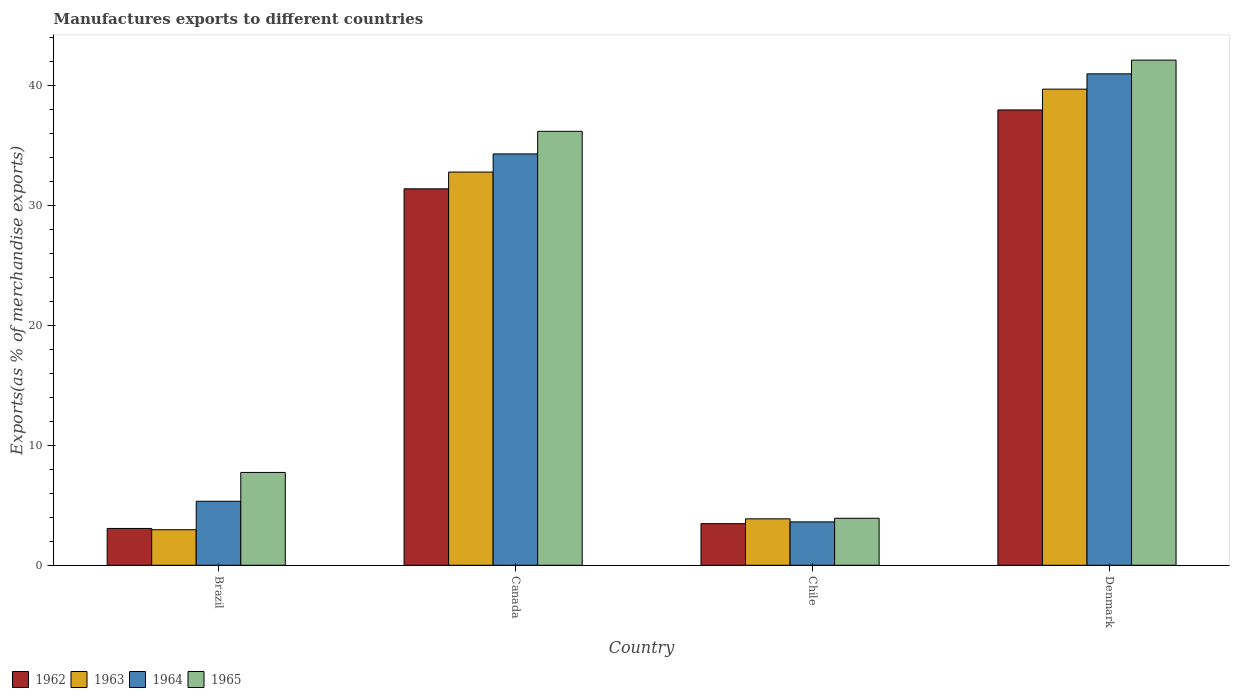How many different coloured bars are there?
Offer a terse response. 4. Are the number of bars per tick equal to the number of legend labels?
Provide a succinct answer. Yes. Are the number of bars on each tick of the X-axis equal?
Provide a succinct answer. Yes. How many bars are there on the 3rd tick from the left?
Your response must be concise. 4. How many bars are there on the 1st tick from the right?
Ensure brevity in your answer.  4. In how many cases, is the number of bars for a given country not equal to the number of legend labels?
Your answer should be very brief. 0. What is the percentage of exports to different countries in 1963 in Denmark?
Give a very brief answer. 39.71. Across all countries, what is the maximum percentage of exports to different countries in 1963?
Offer a terse response. 39.71. Across all countries, what is the minimum percentage of exports to different countries in 1962?
Provide a succinct answer. 3.07. In which country was the percentage of exports to different countries in 1965 maximum?
Ensure brevity in your answer.  Denmark. What is the total percentage of exports to different countries in 1965 in the graph?
Your response must be concise. 89.97. What is the difference between the percentage of exports to different countries in 1965 in Canada and that in Chile?
Your answer should be compact. 32.27. What is the difference between the percentage of exports to different countries in 1963 in Brazil and the percentage of exports to different countries in 1965 in Chile?
Provide a short and direct response. -0.96. What is the average percentage of exports to different countries in 1965 per country?
Ensure brevity in your answer.  22.49. What is the difference between the percentage of exports to different countries of/in 1964 and percentage of exports to different countries of/in 1963 in Brazil?
Ensure brevity in your answer.  2.37. In how many countries, is the percentage of exports to different countries in 1964 greater than 42 %?
Make the answer very short. 0. What is the ratio of the percentage of exports to different countries in 1962 in Brazil to that in Canada?
Offer a very short reply. 0.1. Is the percentage of exports to different countries in 1962 in Brazil less than that in Denmark?
Provide a succinct answer. Yes. Is the difference between the percentage of exports to different countries in 1964 in Chile and Denmark greater than the difference between the percentage of exports to different countries in 1963 in Chile and Denmark?
Your answer should be very brief. No. What is the difference between the highest and the second highest percentage of exports to different countries in 1963?
Keep it short and to the point. 28.92. What is the difference between the highest and the lowest percentage of exports to different countries in 1964?
Your response must be concise. 37.36. In how many countries, is the percentage of exports to different countries in 1965 greater than the average percentage of exports to different countries in 1965 taken over all countries?
Your answer should be very brief. 2. What does the 2nd bar from the left in Brazil represents?
Provide a short and direct response. 1963. What does the 4th bar from the right in Denmark represents?
Offer a very short reply. 1962. Is it the case that in every country, the sum of the percentage of exports to different countries in 1965 and percentage of exports to different countries in 1963 is greater than the percentage of exports to different countries in 1964?
Make the answer very short. Yes. How many bars are there?
Keep it short and to the point. 16. What is the difference between two consecutive major ticks on the Y-axis?
Offer a very short reply. 10. Does the graph contain any zero values?
Offer a very short reply. No. Where does the legend appear in the graph?
Offer a terse response. Bottom left. How many legend labels are there?
Ensure brevity in your answer.  4. How are the legend labels stacked?
Your response must be concise. Horizontal. What is the title of the graph?
Offer a very short reply. Manufactures exports to different countries. What is the label or title of the Y-axis?
Your response must be concise. Exports(as % of merchandise exports). What is the Exports(as % of merchandise exports) of 1962 in Brazil?
Make the answer very short. 3.07. What is the Exports(as % of merchandise exports) in 1963 in Brazil?
Offer a very short reply. 2.96. What is the Exports(as % of merchandise exports) of 1964 in Brazil?
Ensure brevity in your answer.  5.34. What is the Exports(as % of merchandise exports) in 1965 in Brazil?
Keep it short and to the point. 7.74. What is the Exports(as % of merchandise exports) in 1962 in Canada?
Offer a very short reply. 31.39. What is the Exports(as % of merchandise exports) in 1963 in Canada?
Your answer should be compact. 32.79. What is the Exports(as % of merchandise exports) in 1964 in Canada?
Offer a terse response. 34.3. What is the Exports(as % of merchandise exports) in 1965 in Canada?
Make the answer very short. 36.19. What is the Exports(as % of merchandise exports) in 1962 in Chile?
Provide a succinct answer. 3.47. What is the Exports(as % of merchandise exports) in 1963 in Chile?
Give a very brief answer. 3.87. What is the Exports(as % of merchandise exports) of 1964 in Chile?
Your answer should be compact. 3.62. What is the Exports(as % of merchandise exports) in 1965 in Chile?
Offer a very short reply. 3.92. What is the Exports(as % of merchandise exports) in 1962 in Denmark?
Offer a terse response. 37.97. What is the Exports(as % of merchandise exports) of 1963 in Denmark?
Give a very brief answer. 39.71. What is the Exports(as % of merchandise exports) of 1964 in Denmark?
Your answer should be very brief. 40.98. What is the Exports(as % of merchandise exports) in 1965 in Denmark?
Your response must be concise. 42.12. Across all countries, what is the maximum Exports(as % of merchandise exports) in 1962?
Offer a very short reply. 37.97. Across all countries, what is the maximum Exports(as % of merchandise exports) in 1963?
Keep it short and to the point. 39.71. Across all countries, what is the maximum Exports(as % of merchandise exports) of 1964?
Keep it short and to the point. 40.98. Across all countries, what is the maximum Exports(as % of merchandise exports) in 1965?
Make the answer very short. 42.12. Across all countries, what is the minimum Exports(as % of merchandise exports) in 1962?
Offer a terse response. 3.07. Across all countries, what is the minimum Exports(as % of merchandise exports) of 1963?
Provide a short and direct response. 2.96. Across all countries, what is the minimum Exports(as % of merchandise exports) in 1964?
Provide a succinct answer. 3.62. Across all countries, what is the minimum Exports(as % of merchandise exports) in 1965?
Provide a short and direct response. 3.92. What is the total Exports(as % of merchandise exports) in 1962 in the graph?
Make the answer very short. 75.9. What is the total Exports(as % of merchandise exports) of 1963 in the graph?
Ensure brevity in your answer.  79.33. What is the total Exports(as % of merchandise exports) in 1964 in the graph?
Your answer should be compact. 84.24. What is the total Exports(as % of merchandise exports) of 1965 in the graph?
Provide a succinct answer. 89.97. What is the difference between the Exports(as % of merchandise exports) in 1962 in Brazil and that in Canada?
Offer a very short reply. -28.32. What is the difference between the Exports(as % of merchandise exports) in 1963 in Brazil and that in Canada?
Your answer should be very brief. -29.83. What is the difference between the Exports(as % of merchandise exports) of 1964 in Brazil and that in Canada?
Offer a terse response. -28.97. What is the difference between the Exports(as % of merchandise exports) in 1965 in Brazil and that in Canada?
Provide a succinct answer. -28.45. What is the difference between the Exports(as % of merchandise exports) of 1962 in Brazil and that in Chile?
Provide a short and direct response. -0.4. What is the difference between the Exports(as % of merchandise exports) in 1963 in Brazil and that in Chile?
Offer a terse response. -0.91. What is the difference between the Exports(as % of merchandise exports) in 1964 in Brazil and that in Chile?
Give a very brief answer. 1.72. What is the difference between the Exports(as % of merchandise exports) in 1965 in Brazil and that in Chile?
Keep it short and to the point. 3.82. What is the difference between the Exports(as % of merchandise exports) in 1962 in Brazil and that in Denmark?
Your answer should be compact. -34.9. What is the difference between the Exports(as % of merchandise exports) in 1963 in Brazil and that in Denmark?
Keep it short and to the point. -36.74. What is the difference between the Exports(as % of merchandise exports) of 1964 in Brazil and that in Denmark?
Your answer should be very brief. -35.64. What is the difference between the Exports(as % of merchandise exports) of 1965 in Brazil and that in Denmark?
Ensure brevity in your answer.  -34.38. What is the difference between the Exports(as % of merchandise exports) in 1962 in Canada and that in Chile?
Keep it short and to the point. 27.92. What is the difference between the Exports(as % of merchandise exports) of 1963 in Canada and that in Chile?
Your answer should be very brief. 28.92. What is the difference between the Exports(as % of merchandise exports) in 1964 in Canada and that in Chile?
Ensure brevity in your answer.  30.69. What is the difference between the Exports(as % of merchandise exports) of 1965 in Canada and that in Chile?
Your answer should be very brief. 32.27. What is the difference between the Exports(as % of merchandise exports) in 1962 in Canada and that in Denmark?
Ensure brevity in your answer.  -6.58. What is the difference between the Exports(as % of merchandise exports) of 1963 in Canada and that in Denmark?
Make the answer very short. -6.92. What is the difference between the Exports(as % of merchandise exports) in 1964 in Canada and that in Denmark?
Offer a very short reply. -6.68. What is the difference between the Exports(as % of merchandise exports) in 1965 in Canada and that in Denmark?
Make the answer very short. -5.94. What is the difference between the Exports(as % of merchandise exports) of 1962 in Chile and that in Denmark?
Give a very brief answer. -34.5. What is the difference between the Exports(as % of merchandise exports) of 1963 in Chile and that in Denmark?
Your answer should be compact. -35.84. What is the difference between the Exports(as % of merchandise exports) in 1964 in Chile and that in Denmark?
Offer a very short reply. -37.36. What is the difference between the Exports(as % of merchandise exports) of 1965 in Chile and that in Denmark?
Provide a short and direct response. -38.21. What is the difference between the Exports(as % of merchandise exports) in 1962 in Brazil and the Exports(as % of merchandise exports) in 1963 in Canada?
Offer a terse response. -29.72. What is the difference between the Exports(as % of merchandise exports) in 1962 in Brazil and the Exports(as % of merchandise exports) in 1964 in Canada?
Ensure brevity in your answer.  -31.23. What is the difference between the Exports(as % of merchandise exports) in 1962 in Brazil and the Exports(as % of merchandise exports) in 1965 in Canada?
Make the answer very short. -33.12. What is the difference between the Exports(as % of merchandise exports) in 1963 in Brazil and the Exports(as % of merchandise exports) in 1964 in Canada?
Offer a terse response. -31.34. What is the difference between the Exports(as % of merchandise exports) of 1963 in Brazil and the Exports(as % of merchandise exports) of 1965 in Canada?
Give a very brief answer. -33.23. What is the difference between the Exports(as % of merchandise exports) in 1964 in Brazil and the Exports(as % of merchandise exports) in 1965 in Canada?
Make the answer very short. -30.85. What is the difference between the Exports(as % of merchandise exports) of 1962 in Brazil and the Exports(as % of merchandise exports) of 1963 in Chile?
Provide a short and direct response. -0.8. What is the difference between the Exports(as % of merchandise exports) of 1962 in Brazil and the Exports(as % of merchandise exports) of 1964 in Chile?
Provide a succinct answer. -0.55. What is the difference between the Exports(as % of merchandise exports) of 1962 in Brazil and the Exports(as % of merchandise exports) of 1965 in Chile?
Ensure brevity in your answer.  -0.85. What is the difference between the Exports(as % of merchandise exports) of 1963 in Brazil and the Exports(as % of merchandise exports) of 1964 in Chile?
Give a very brief answer. -0.66. What is the difference between the Exports(as % of merchandise exports) of 1963 in Brazil and the Exports(as % of merchandise exports) of 1965 in Chile?
Offer a very short reply. -0.96. What is the difference between the Exports(as % of merchandise exports) in 1964 in Brazil and the Exports(as % of merchandise exports) in 1965 in Chile?
Give a very brief answer. 1.42. What is the difference between the Exports(as % of merchandise exports) of 1962 in Brazil and the Exports(as % of merchandise exports) of 1963 in Denmark?
Offer a very short reply. -36.64. What is the difference between the Exports(as % of merchandise exports) in 1962 in Brazil and the Exports(as % of merchandise exports) in 1964 in Denmark?
Offer a terse response. -37.91. What is the difference between the Exports(as % of merchandise exports) of 1962 in Brazil and the Exports(as % of merchandise exports) of 1965 in Denmark?
Provide a succinct answer. -39.05. What is the difference between the Exports(as % of merchandise exports) of 1963 in Brazil and the Exports(as % of merchandise exports) of 1964 in Denmark?
Give a very brief answer. -38.02. What is the difference between the Exports(as % of merchandise exports) in 1963 in Brazil and the Exports(as % of merchandise exports) in 1965 in Denmark?
Offer a terse response. -39.16. What is the difference between the Exports(as % of merchandise exports) in 1964 in Brazil and the Exports(as % of merchandise exports) in 1965 in Denmark?
Provide a succinct answer. -36.79. What is the difference between the Exports(as % of merchandise exports) of 1962 in Canada and the Exports(as % of merchandise exports) of 1963 in Chile?
Ensure brevity in your answer.  27.52. What is the difference between the Exports(as % of merchandise exports) of 1962 in Canada and the Exports(as % of merchandise exports) of 1964 in Chile?
Make the answer very short. 27.77. What is the difference between the Exports(as % of merchandise exports) in 1962 in Canada and the Exports(as % of merchandise exports) in 1965 in Chile?
Make the answer very short. 27.47. What is the difference between the Exports(as % of merchandise exports) in 1963 in Canada and the Exports(as % of merchandise exports) in 1964 in Chile?
Make the answer very short. 29.17. What is the difference between the Exports(as % of merchandise exports) in 1963 in Canada and the Exports(as % of merchandise exports) in 1965 in Chile?
Ensure brevity in your answer.  28.87. What is the difference between the Exports(as % of merchandise exports) of 1964 in Canada and the Exports(as % of merchandise exports) of 1965 in Chile?
Provide a succinct answer. 30.39. What is the difference between the Exports(as % of merchandise exports) of 1962 in Canada and the Exports(as % of merchandise exports) of 1963 in Denmark?
Make the answer very short. -8.31. What is the difference between the Exports(as % of merchandise exports) in 1962 in Canada and the Exports(as % of merchandise exports) in 1964 in Denmark?
Keep it short and to the point. -9.59. What is the difference between the Exports(as % of merchandise exports) of 1962 in Canada and the Exports(as % of merchandise exports) of 1965 in Denmark?
Ensure brevity in your answer.  -10.73. What is the difference between the Exports(as % of merchandise exports) of 1963 in Canada and the Exports(as % of merchandise exports) of 1964 in Denmark?
Make the answer very short. -8.19. What is the difference between the Exports(as % of merchandise exports) of 1963 in Canada and the Exports(as % of merchandise exports) of 1965 in Denmark?
Ensure brevity in your answer.  -9.33. What is the difference between the Exports(as % of merchandise exports) in 1964 in Canada and the Exports(as % of merchandise exports) in 1965 in Denmark?
Your answer should be compact. -7.82. What is the difference between the Exports(as % of merchandise exports) of 1962 in Chile and the Exports(as % of merchandise exports) of 1963 in Denmark?
Offer a terse response. -36.24. What is the difference between the Exports(as % of merchandise exports) of 1962 in Chile and the Exports(as % of merchandise exports) of 1964 in Denmark?
Give a very brief answer. -37.51. What is the difference between the Exports(as % of merchandise exports) in 1962 in Chile and the Exports(as % of merchandise exports) in 1965 in Denmark?
Provide a succinct answer. -38.66. What is the difference between the Exports(as % of merchandise exports) of 1963 in Chile and the Exports(as % of merchandise exports) of 1964 in Denmark?
Provide a succinct answer. -37.11. What is the difference between the Exports(as % of merchandise exports) of 1963 in Chile and the Exports(as % of merchandise exports) of 1965 in Denmark?
Your response must be concise. -38.25. What is the difference between the Exports(as % of merchandise exports) of 1964 in Chile and the Exports(as % of merchandise exports) of 1965 in Denmark?
Provide a short and direct response. -38.51. What is the average Exports(as % of merchandise exports) in 1962 per country?
Make the answer very short. 18.98. What is the average Exports(as % of merchandise exports) in 1963 per country?
Your answer should be very brief. 19.83. What is the average Exports(as % of merchandise exports) in 1964 per country?
Give a very brief answer. 21.06. What is the average Exports(as % of merchandise exports) of 1965 per country?
Make the answer very short. 22.49. What is the difference between the Exports(as % of merchandise exports) in 1962 and Exports(as % of merchandise exports) in 1963 in Brazil?
Give a very brief answer. 0.11. What is the difference between the Exports(as % of merchandise exports) of 1962 and Exports(as % of merchandise exports) of 1964 in Brazil?
Offer a terse response. -2.27. What is the difference between the Exports(as % of merchandise exports) of 1962 and Exports(as % of merchandise exports) of 1965 in Brazil?
Your answer should be compact. -4.67. What is the difference between the Exports(as % of merchandise exports) in 1963 and Exports(as % of merchandise exports) in 1964 in Brazil?
Make the answer very short. -2.37. What is the difference between the Exports(as % of merchandise exports) in 1963 and Exports(as % of merchandise exports) in 1965 in Brazil?
Your answer should be compact. -4.78. What is the difference between the Exports(as % of merchandise exports) in 1964 and Exports(as % of merchandise exports) in 1965 in Brazil?
Make the answer very short. -2.4. What is the difference between the Exports(as % of merchandise exports) of 1962 and Exports(as % of merchandise exports) of 1963 in Canada?
Keep it short and to the point. -1.4. What is the difference between the Exports(as % of merchandise exports) in 1962 and Exports(as % of merchandise exports) in 1964 in Canada?
Your answer should be very brief. -2.91. What is the difference between the Exports(as % of merchandise exports) in 1962 and Exports(as % of merchandise exports) in 1965 in Canada?
Your answer should be compact. -4.8. What is the difference between the Exports(as % of merchandise exports) of 1963 and Exports(as % of merchandise exports) of 1964 in Canada?
Your answer should be very brief. -1.51. What is the difference between the Exports(as % of merchandise exports) of 1963 and Exports(as % of merchandise exports) of 1965 in Canada?
Give a very brief answer. -3.4. What is the difference between the Exports(as % of merchandise exports) of 1964 and Exports(as % of merchandise exports) of 1965 in Canada?
Ensure brevity in your answer.  -1.89. What is the difference between the Exports(as % of merchandise exports) in 1962 and Exports(as % of merchandise exports) in 1963 in Chile?
Your answer should be compact. -0.4. What is the difference between the Exports(as % of merchandise exports) of 1962 and Exports(as % of merchandise exports) of 1964 in Chile?
Offer a terse response. -0.15. What is the difference between the Exports(as % of merchandise exports) of 1962 and Exports(as % of merchandise exports) of 1965 in Chile?
Provide a short and direct response. -0.45. What is the difference between the Exports(as % of merchandise exports) of 1963 and Exports(as % of merchandise exports) of 1964 in Chile?
Ensure brevity in your answer.  0.25. What is the difference between the Exports(as % of merchandise exports) in 1963 and Exports(as % of merchandise exports) in 1965 in Chile?
Offer a very short reply. -0.05. What is the difference between the Exports(as % of merchandise exports) of 1964 and Exports(as % of merchandise exports) of 1965 in Chile?
Provide a short and direct response. -0.3. What is the difference between the Exports(as % of merchandise exports) in 1962 and Exports(as % of merchandise exports) in 1963 in Denmark?
Ensure brevity in your answer.  -1.74. What is the difference between the Exports(as % of merchandise exports) in 1962 and Exports(as % of merchandise exports) in 1964 in Denmark?
Offer a very short reply. -3.01. What is the difference between the Exports(as % of merchandise exports) in 1962 and Exports(as % of merchandise exports) in 1965 in Denmark?
Offer a very short reply. -4.15. What is the difference between the Exports(as % of merchandise exports) in 1963 and Exports(as % of merchandise exports) in 1964 in Denmark?
Make the answer very short. -1.27. What is the difference between the Exports(as % of merchandise exports) of 1963 and Exports(as % of merchandise exports) of 1965 in Denmark?
Make the answer very short. -2.42. What is the difference between the Exports(as % of merchandise exports) of 1964 and Exports(as % of merchandise exports) of 1965 in Denmark?
Keep it short and to the point. -1.14. What is the ratio of the Exports(as % of merchandise exports) in 1962 in Brazil to that in Canada?
Keep it short and to the point. 0.1. What is the ratio of the Exports(as % of merchandise exports) in 1963 in Brazil to that in Canada?
Your response must be concise. 0.09. What is the ratio of the Exports(as % of merchandise exports) in 1964 in Brazil to that in Canada?
Provide a succinct answer. 0.16. What is the ratio of the Exports(as % of merchandise exports) of 1965 in Brazil to that in Canada?
Make the answer very short. 0.21. What is the ratio of the Exports(as % of merchandise exports) in 1962 in Brazil to that in Chile?
Provide a short and direct response. 0.89. What is the ratio of the Exports(as % of merchandise exports) of 1963 in Brazil to that in Chile?
Provide a succinct answer. 0.77. What is the ratio of the Exports(as % of merchandise exports) of 1964 in Brazil to that in Chile?
Ensure brevity in your answer.  1.48. What is the ratio of the Exports(as % of merchandise exports) in 1965 in Brazil to that in Chile?
Your response must be concise. 1.98. What is the ratio of the Exports(as % of merchandise exports) in 1962 in Brazil to that in Denmark?
Your answer should be compact. 0.08. What is the ratio of the Exports(as % of merchandise exports) of 1963 in Brazil to that in Denmark?
Your response must be concise. 0.07. What is the ratio of the Exports(as % of merchandise exports) of 1964 in Brazil to that in Denmark?
Your response must be concise. 0.13. What is the ratio of the Exports(as % of merchandise exports) in 1965 in Brazil to that in Denmark?
Offer a terse response. 0.18. What is the ratio of the Exports(as % of merchandise exports) in 1962 in Canada to that in Chile?
Provide a succinct answer. 9.05. What is the ratio of the Exports(as % of merchandise exports) in 1963 in Canada to that in Chile?
Your response must be concise. 8.47. What is the ratio of the Exports(as % of merchandise exports) of 1964 in Canada to that in Chile?
Make the answer very short. 9.48. What is the ratio of the Exports(as % of merchandise exports) in 1965 in Canada to that in Chile?
Give a very brief answer. 9.24. What is the ratio of the Exports(as % of merchandise exports) of 1962 in Canada to that in Denmark?
Provide a short and direct response. 0.83. What is the ratio of the Exports(as % of merchandise exports) in 1963 in Canada to that in Denmark?
Offer a very short reply. 0.83. What is the ratio of the Exports(as % of merchandise exports) of 1964 in Canada to that in Denmark?
Give a very brief answer. 0.84. What is the ratio of the Exports(as % of merchandise exports) of 1965 in Canada to that in Denmark?
Make the answer very short. 0.86. What is the ratio of the Exports(as % of merchandise exports) of 1962 in Chile to that in Denmark?
Offer a terse response. 0.09. What is the ratio of the Exports(as % of merchandise exports) of 1963 in Chile to that in Denmark?
Make the answer very short. 0.1. What is the ratio of the Exports(as % of merchandise exports) in 1964 in Chile to that in Denmark?
Provide a short and direct response. 0.09. What is the ratio of the Exports(as % of merchandise exports) in 1965 in Chile to that in Denmark?
Provide a succinct answer. 0.09. What is the difference between the highest and the second highest Exports(as % of merchandise exports) of 1962?
Provide a short and direct response. 6.58. What is the difference between the highest and the second highest Exports(as % of merchandise exports) of 1963?
Keep it short and to the point. 6.92. What is the difference between the highest and the second highest Exports(as % of merchandise exports) of 1964?
Offer a terse response. 6.68. What is the difference between the highest and the second highest Exports(as % of merchandise exports) in 1965?
Ensure brevity in your answer.  5.94. What is the difference between the highest and the lowest Exports(as % of merchandise exports) in 1962?
Ensure brevity in your answer.  34.9. What is the difference between the highest and the lowest Exports(as % of merchandise exports) of 1963?
Your response must be concise. 36.74. What is the difference between the highest and the lowest Exports(as % of merchandise exports) of 1964?
Provide a succinct answer. 37.36. What is the difference between the highest and the lowest Exports(as % of merchandise exports) of 1965?
Give a very brief answer. 38.21. 